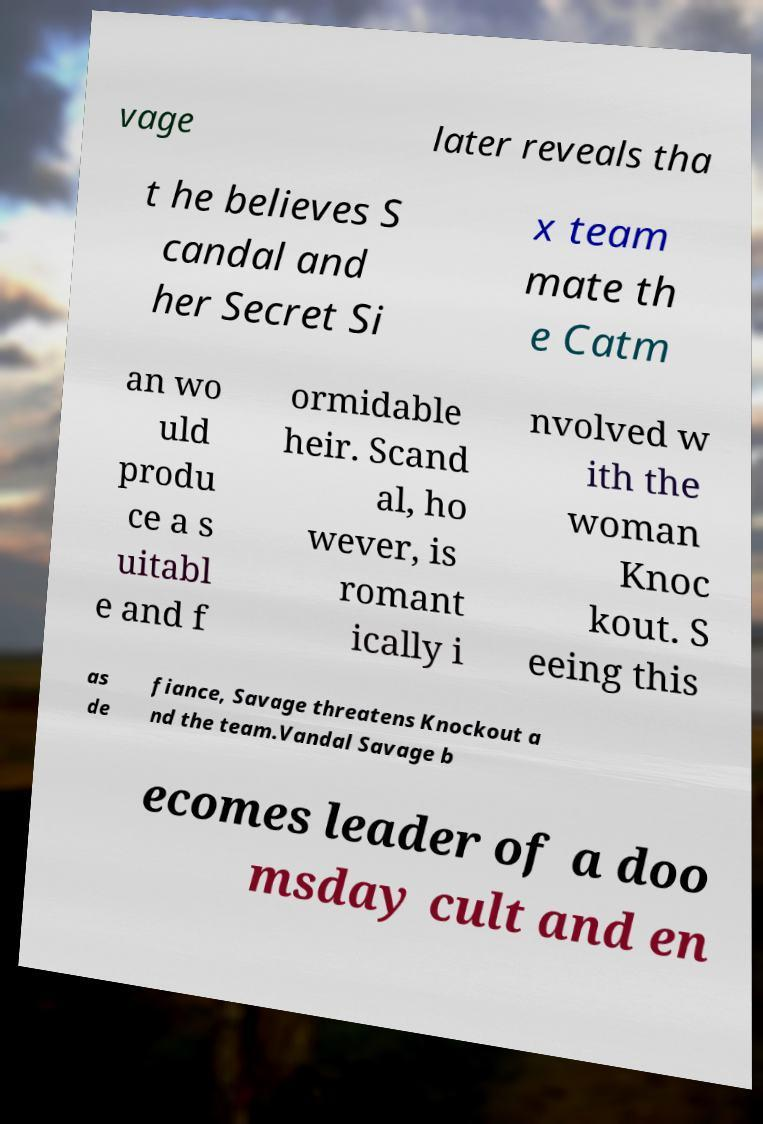Please identify and transcribe the text found in this image. vage later reveals tha t he believes S candal and her Secret Si x team mate th e Catm an wo uld produ ce a s uitabl e and f ormidable heir. Scand al, ho wever, is romant ically i nvolved w ith the woman Knoc kout. S eeing this as de fiance, Savage threatens Knockout a nd the team.Vandal Savage b ecomes leader of a doo msday cult and en 